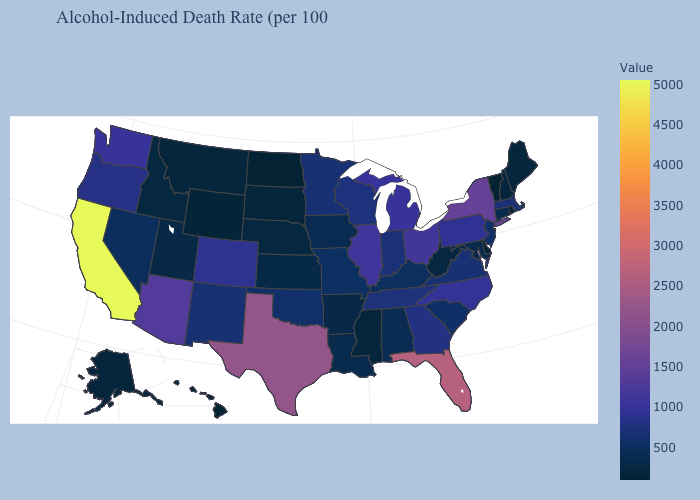Which states have the lowest value in the MidWest?
Quick response, please. North Dakota. Among the states that border Ohio , which have the highest value?
Write a very short answer. Michigan. Which states hav the highest value in the MidWest?
Answer briefly. Ohio. Does California have the highest value in the West?
Be succinct. Yes. Does the map have missing data?
Write a very short answer. No. Does Hawaii have the lowest value in the USA?
Write a very short answer. Yes. Which states have the highest value in the USA?
Answer briefly. California. Does New York have the highest value in the Northeast?
Give a very brief answer. Yes. 